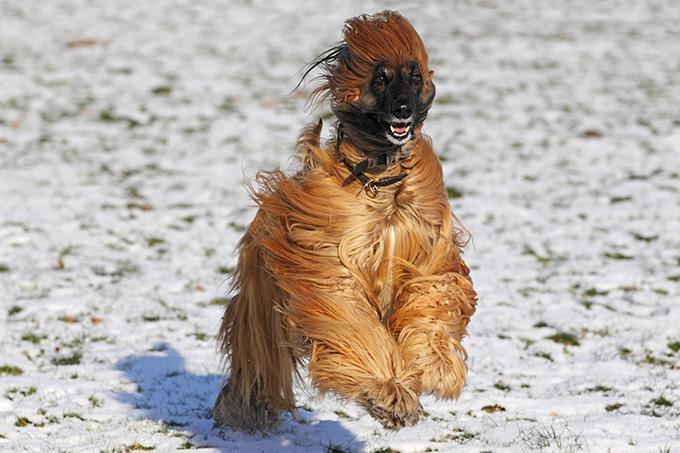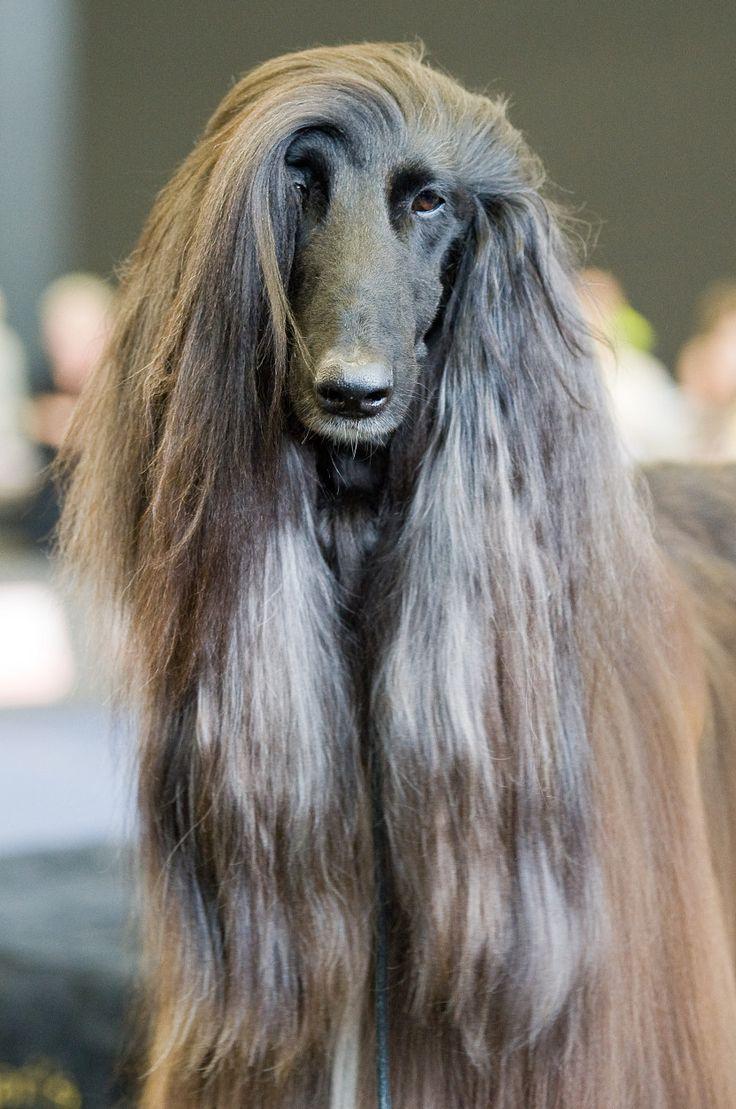The first image is the image on the left, the second image is the image on the right. For the images shown, is this caption "One image features an afghan hound with long gray hair on its head that looks like a woman's wig, and the other image features an afghan hound with a very different look." true? Answer yes or no. Yes. The first image is the image on the left, the second image is the image on the right. For the images displayed, is the sentence "The dog in the image in the left has its mouth open." factually correct? Answer yes or no. Yes. 